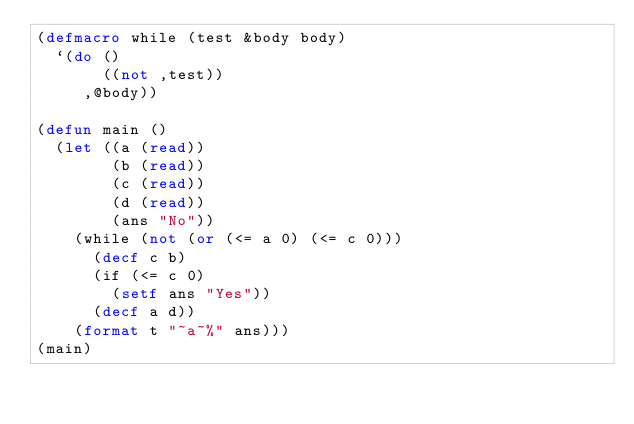Convert code to text. <code><loc_0><loc_0><loc_500><loc_500><_Lisp_>(defmacro while (test &body body)
  `(do ()
       ((not ,test))
     ,@body))

(defun main ()
  (let ((a (read))
        (b (read))
        (c (read))
        (d (read))
        (ans "No"))
    (while (not (or (<= a 0) (<= c 0)))
      (decf c b)
      (if (<= c 0)
        (setf ans "Yes"))
      (decf a d))
    (format t "~a~%" ans)))
(main)
</code> 